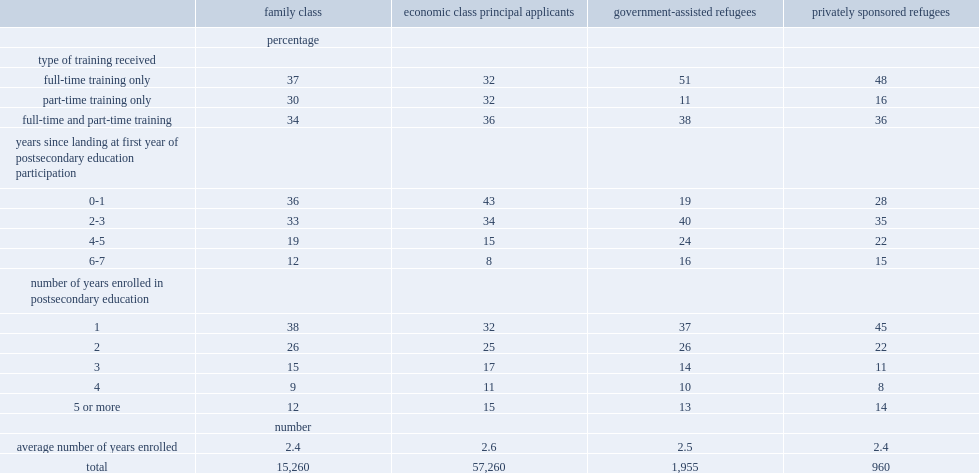What percentage of refugees who tend to study in their first year in canada has gars? 19.0. What percentage of refugees who tend to study in their first year in canada has psrs? 28.0. What percentage of refugees who tend to study in their first year in canada has family class? 36.0. What percentage of refugees who tend to study in their first year in canada has economic class principal applicants? 43.0. 